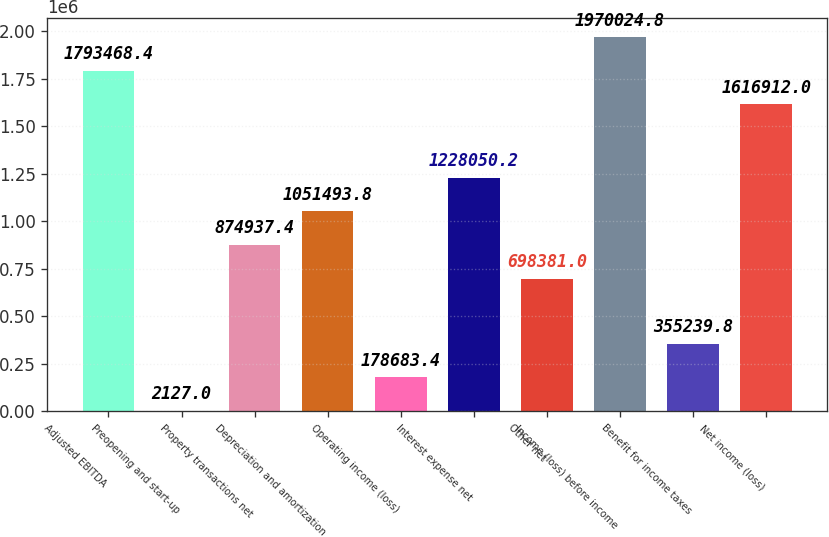Convert chart. <chart><loc_0><loc_0><loc_500><loc_500><bar_chart><fcel>Adjusted EBITDA<fcel>Preopening and start-up<fcel>Property transactions net<fcel>Depreciation and amortization<fcel>Operating income (loss)<fcel>Interest expense net<fcel>Other net<fcel>Income (loss) before income<fcel>Benefit for income taxes<fcel>Net income (loss)<nl><fcel>1.79347e+06<fcel>2127<fcel>874937<fcel>1.05149e+06<fcel>178683<fcel>1.22805e+06<fcel>698381<fcel>1.97002e+06<fcel>355240<fcel>1.61691e+06<nl></chart> 